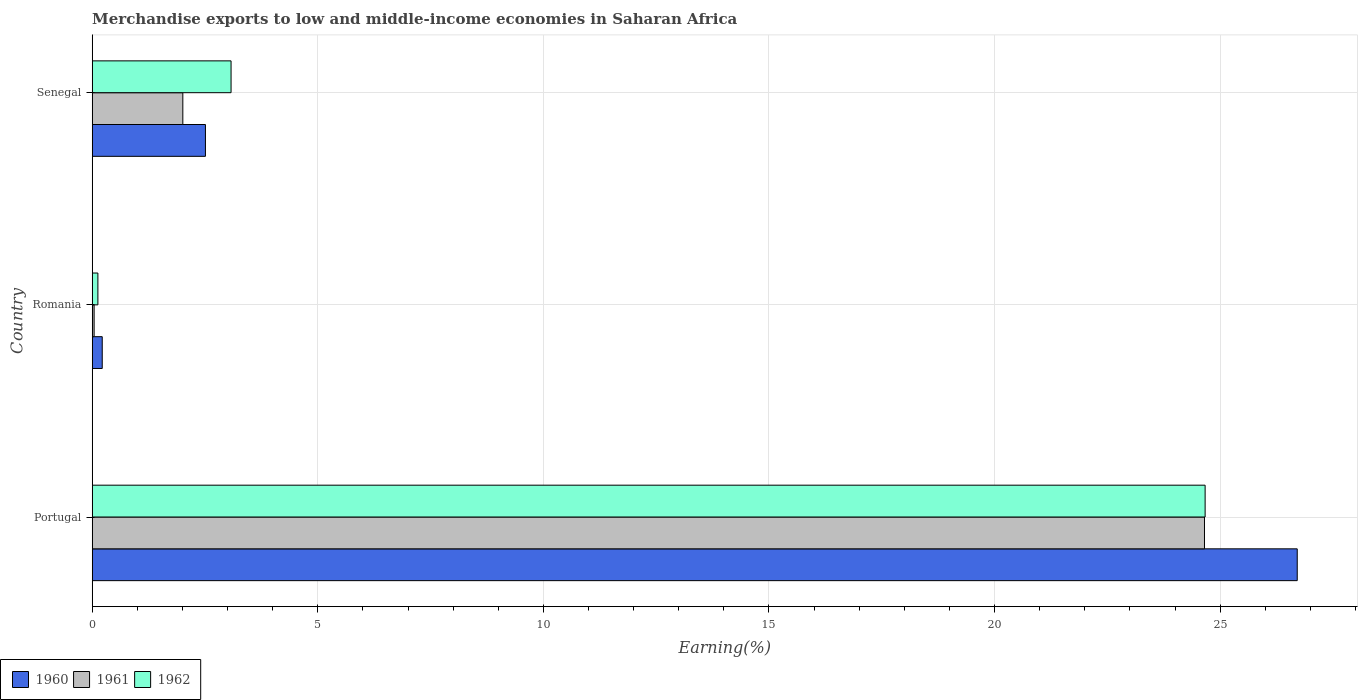How many different coloured bars are there?
Offer a very short reply. 3. Are the number of bars per tick equal to the number of legend labels?
Ensure brevity in your answer.  Yes. Are the number of bars on each tick of the Y-axis equal?
Your response must be concise. Yes. What is the label of the 3rd group of bars from the top?
Give a very brief answer. Portugal. In how many cases, is the number of bars for a given country not equal to the number of legend labels?
Your answer should be very brief. 0. What is the percentage of amount earned from merchandise exports in 1962 in Portugal?
Provide a short and direct response. 24.67. Across all countries, what is the maximum percentage of amount earned from merchandise exports in 1961?
Your response must be concise. 24.65. Across all countries, what is the minimum percentage of amount earned from merchandise exports in 1962?
Your answer should be very brief. 0.13. In which country was the percentage of amount earned from merchandise exports in 1961 minimum?
Your response must be concise. Romania. What is the total percentage of amount earned from merchandise exports in 1961 in the graph?
Your answer should be compact. 26.7. What is the difference between the percentage of amount earned from merchandise exports in 1960 in Portugal and that in Romania?
Your response must be concise. 26.49. What is the difference between the percentage of amount earned from merchandise exports in 1960 in Romania and the percentage of amount earned from merchandise exports in 1961 in Senegal?
Keep it short and to the point. -1.79. What is the average percentage of amount earned from merchandise exports in 1960 per country?
Ensure brevity in your answer.  9.81. What is the difference between the percentage of amount earned from merchandise exports in 1962 and percentage of amount earned from merchandise exports in 1960 in Portugal?
Ensure brevity in your answer.  -2.04. In how many countries, is the percentage of amount earned from merchandise exports in 1962 greater than 8 %?
Keep it short and to the point. 1. What is the ratio of the percentage of amount earned from merchandise exports in 1962 in Portugal to that in Senegal?
Offer a terse response. 8.02. What is the difference between the highest and the second highest percentage of amount earned from merchandise exports in 1961?
Make the answer very short. 22.65. What is the difference between the highest and the lowest percentage of amount earned from merchandise exports in 1960?
Offer a terse response. 26.49. In how many countries, is the percentage of amount earned from merchandise exports in 1962 greater than the average percentage of amount earned from merchandise exports in 1962 taken over all countries?
Ensure brevity in your answer.  1. What does the 3rd bar from the top in Senegal represents?
Ensure brevity in your answer.  1960. How many bars are there?
Make the answer very short. 9. How many countries are there in the graph?
Your answer should be very brief. 3. What is the difference between two consecutive major ticks on the X-axis?
Keep it short and to the point. 5. Are the values on the major ticks of X-axis written in scientific E-notation?
Your answer should be very brief. No. Does the graph contain any zero values?
Provide a short and direct response. No. What is the title of the graph?
Ensure brevity in your answer.  Merchandise exports to low and middle-income economies in Saharan Africa. Does "1964" appear as one of the legend labels in the graph?
Provide a succinct answer. No. What is the label or title of the X-axis?
Provide a succinct answer. Earning(%). What is the label or title of the Y-axis?
Your answer should be very brief. Country. What is the Earning(%) in 1960 in Portugal?
Your response must be concise. 26.71. What is the Earning(%) of 1961 in Portugal?
Offer a terse response. 24.65. What is the Earning(%) in 1962 in Portugal?
Provide a short and direct response. 24.67. What is the Earning(%) in 1960 in Romania?
Your response must be concise. 0.22. What is the Earning(%) of 1961 in Romania?
Make the answer very short. 0.04. What is the Earning(%) of 1962 in Romania?
Offer a terse response. 0.13. What is the Earning(%) in 1960 in Senegal?
Your answer should be compact. 2.51. What is the Earning(%) of 1961 in Senegal?
Make the answer very short. 2.01. What is the Earning(%) of 1962 in Senegal?
Your answer should be compact. 3.08. Across all countries, what is the maximum Earning(%) in 1960?
Your answer should be compact. 26.71. Across all countries, what is the maximum Earning(%) of 1961?
Your answer should be compact. 24.65. Across all countries, what is the maximum Earning(%) of 1962?
Your response must be concise. 24.67. Across all countries, what is the minimum Earning(%) in 1960?
Make the answer very short. 0.22. Across all countries, what is the minimum Earning(%) of 1961?
Provide a succinct answer. 0.04. Across all countries, what is the minimum Earning(%) in 1962?
Your response must be concise. 0.13. What is the total Earning(%) in 1960 in the graph?
Your response must be concise. 29.44. What is the total Earning(%) of 1961 in the graph?
Your answer should be compact. 26.7. What is the total Earning(%) of 1962 in the graph?
Your response must be concise. 27.87. What is the difference between the Earning(%) of 1960 in Portugal and that in Romania?
Make the answer very short. 26.49. What is the difference between the Earning(%) in 1961 in Portugal and that in Romania?
Make the answer very short. 24.61. What is the difference between the Earning(%) of 1962 in Portugal and that in Romania?
Make the answer very short. 24.54. What is the difference between the Earning(%) in 1960 in Portugal and that in Senegal?
Provide a succinct answer. 24.2. What is the difference between the Earning(%) of 1961 in Portugal and that in Senegal?
Provide a succinct answer. 22.65. What is the difference between the Earning(%) of 1962 in Portugal and that in Senegal?
Your answer should be compact. 21.59. What is the difference between the Earning(%) of 1960 in Romania and that in Senegal?
Offer a terse response. -2.29. What is the difference between the Earning(%) in 1961 in Romania and that in Senegal?
Your response must be concise. -1.97. What is the difference between the Earning(%) of 1962 in Romania and that in Senegal?
Provide a succinct answer. -2.95. What is the difference between the Earning(%) of 1960 in Portugal and the Earning(%) of 1961 in Romania?
Offer a terse response. 26.67. What is the difference between the Earning(%) in 1960 in Portugal and the Earning(%) in 1962 in Romania?
Keep it short and to the point. 26.58. What is the difference between the Earning(%) of 1961 in Portugal and the Earning(%) of 1962 in Romania?
Keep it short and to the point. 24.53. What is the difference between the Earning(%) in 1960 in Portugal and the Earning(%) in 1961 in Senegal?
Give a very brief answer. 24.7. What is the difference between the Earning(%) in 1960 in Portugal and the Earning(%) in 1962 in Senegal?
Make the answer very short. 23.63. What is the difference between the Earning(%) in 1961 in Portugal and the Earning(%) in 1962 in Senegal?
Your answer should be very brief. 21.58. What is the difference between the Earning(%) in 1960 in Romania and the Earning(%) in 1961 in Senegal?
Provide a short and direct response. -1.79. What is the difference between the Earning(%) in 1960 in Romania and the Earning(%) in 1962 in Senegal?
Your answer should be very brief. -2.86. What is the difference between the Earning(%) in 1961 in Romania and the Earning(%) in 1962 in Senegal?
Provide a short and direct response. -3.04. What is the average Earning(%) in 1960 per country?
Offer a very short reply. 9.81. What is the average Earning(%) in 1961 per country?
Ensure brevity in your answer.  8.9. What is the average Earning(%) of 1962 per country?
Offer a terse response. 9.29. What is the difference between the Earning(%) of 1960 and Earning(%) of 1961 in Portugal?
Make the answer very short. 2.06. What is the difference between the Earning(%) of 1960 and Earning(%) of 1962 in Portugal?
Provide a succinct answer. 2.04. What is the difference between the Earning(%) in 1961 and Earning(%) in 1962 in Portugal?
Your response must be concise. -0.01. What is the difference between the Earning(%) of 1960 and Earning(%) of 1961 in Romania?
Your answer should be very brief. 0.18. What is the difference between the Earning(%) in 1960 and Earning(%) in 1962 in Romania?
Provide a succinct answer. 0.1. What is the difference between the Earning(%) in 1961 and Earning(%) in 1962 in Romania?
Your response must be concise. -0.08. What is the difference between the Earning(%) of 1960 and Earning(%) of 1961 in Senegal?
Make the answer very short. 0.5. What is the difference between the Earning(%) of 1960 and Earning(%) of 1962 in Senegal?
Provide a succinct answer. -0.57. What is the difference between the Earning(%) in 1961 and Earning(%) in 1962 in Senegal?
Give a very brief answer. -1.07. What is the ratio of the Earning(%) in 1960 in Portugal to that in Romania?
Ensure brevity in your answer.  120.48. What is the ratio of the Earning(%) of 1961 in Portugal to that in Romania?
Give a very brief answer. 588.91. What is the ratio of the Earning(%) in 1962 in Portugal to that in Romania?
Your response must be concise. 196.67. What is the ratio of the Earning(%) in 1960 in Portugal to that in Senegal?
Give a very brief answer. 10.65. What is the ratio of the Earning(%) in 1961 in Portugal to that in Senegal?
Offer a very short reply. 12.28. What is the ratio of the Earning(%) of 1962 in Portugal to that in Senegal?
Provide a succinct answer. 8.02. What is the ratio of the Earning(%) of 1960 in Romania to that in Senegal?
Provide a succinct answer. 0.09. What is the ratio of the Earning(%) in 1961 in Romania to that in Senegal?
Ensure brevity in your answer.  0.02. What is the ratio of the Earning(%) in 1962 in Romania to that in Senegal?
Give a very brief answer. 0.04. What is the difference between the highest and the second highest Earning(%) of 1960?
Your answer should be very brief. 24.2. What is the difference between the highest and the second highest Earning(%) in 1961?
Keep it short and to the point. 22.65. What is the difference between the highest and the second highest Earning(%) in 1962?
Provide a short and direct response. 21.59. What is the difference between the highest and the lowest Earning(%) in 1960?
Provide a succinct answer. 26.49. What is the difference between the highest and the lowest Earning(%) of 1961?
Your answer should be very brief. 24.61. What is the difference between the highest and the lowest Earning(%) of 1962?
Provide a short and direct response. 24.54. 